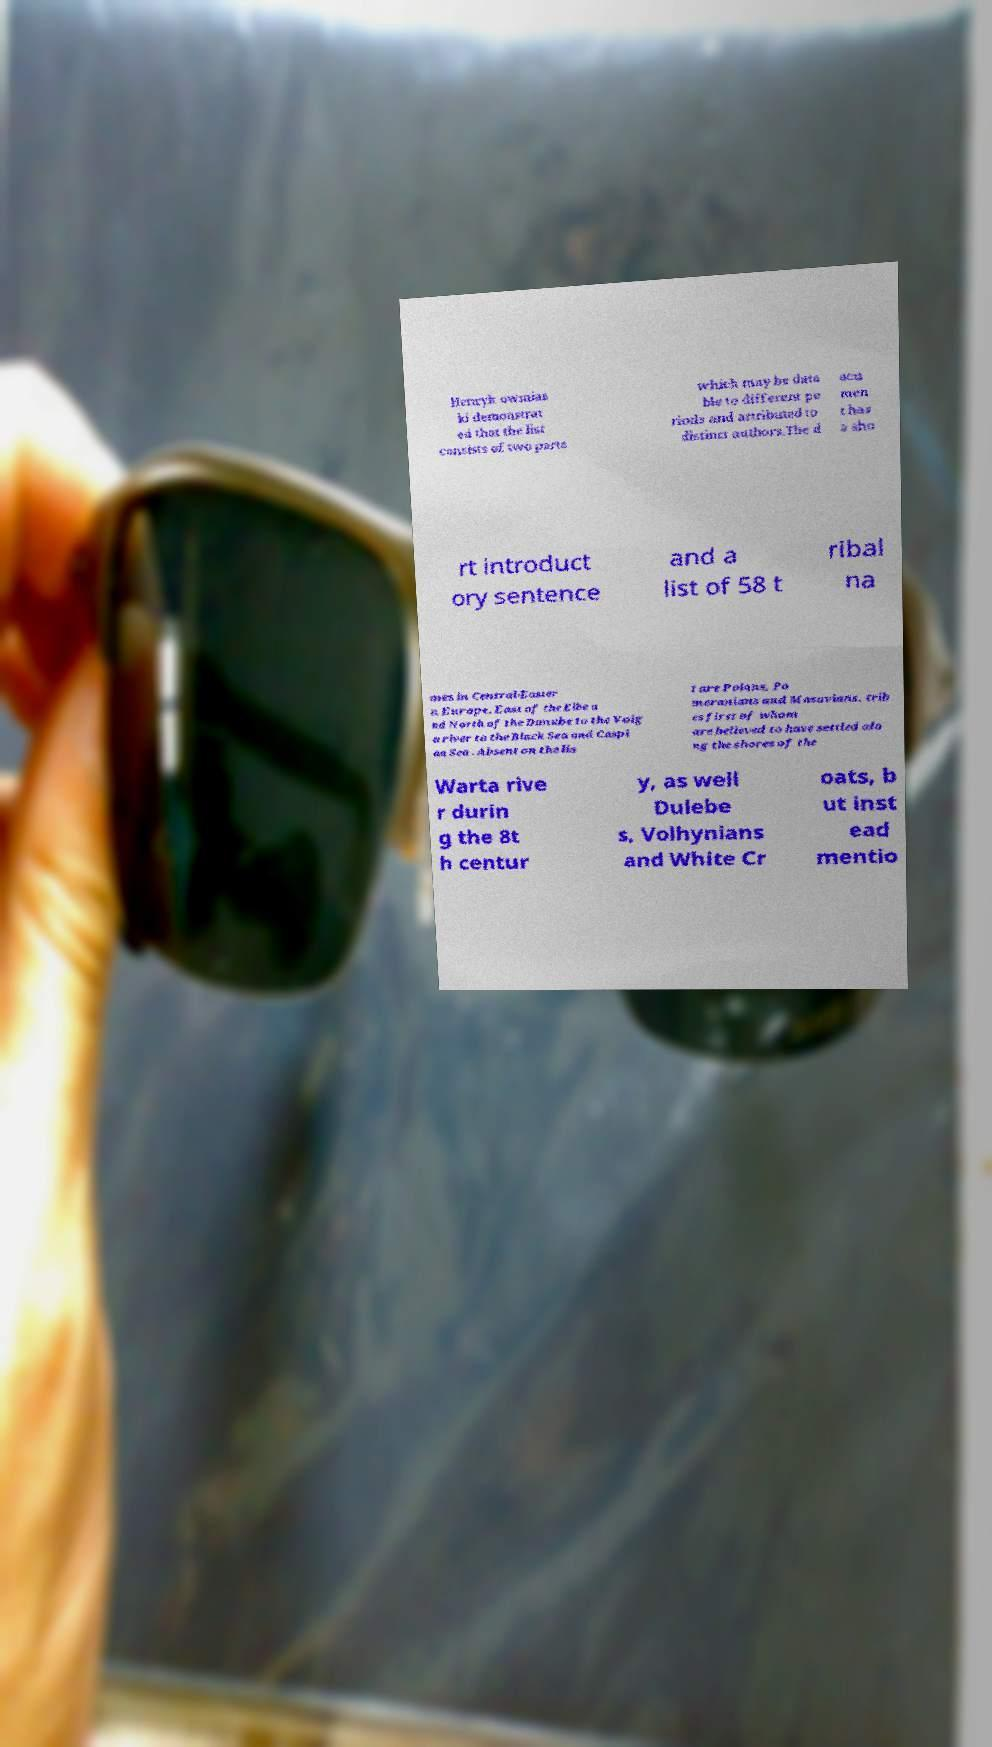Please read and relay the text visible in this image. What does it say? Henryk owmias ki demonstrat ed that the list consists of two parts which may be data ble to different pe riods and attributed to distinct authors.The d ocu men t has a sho rt introduct ory sentence and a list of 58 t ribal na mes in Central-Easter n Europe, East of the Elbe a nd North of the Danube to the Volg a river to the Black Sea and Caspi an Sea . Absent on the lis t are Polans, Po meranians and Masovians, trib es first of whom are believed to have settled alo ng the shores of the Warta rive r durin g the 8t h centur y, as well Dulebe s, Volhynians and White Cr oats, b ut inst ead mentio 